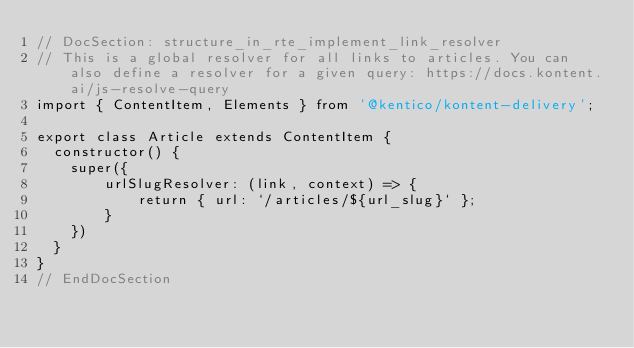Convert code to text. <code><loc_0><loc_0><loc_500><loc_500><_TypeScript_>// DocSection: structure_in_rte_implement_link_resolver
// This is a global resolver for all links to articles. You can also define a resolver for a given query: https://docs.kontent.ai/js-resolve-query
import { ContentItem, Elements } from '@kentico/kontent-delivery';

export class Article extends ContentItem {
  constructor() {
    super({
        urlSlugResolver: (link, context) => {
            return { url: `/articles/${url_slug}` };
        }
    })
  }
}
// EndDocSection</code> 